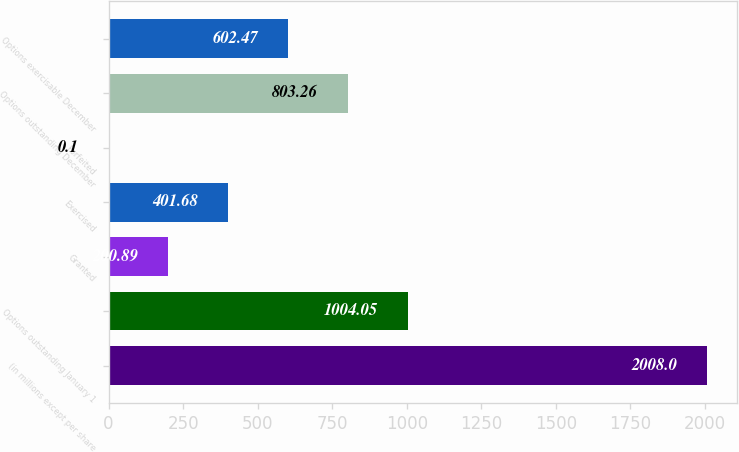<chart> <loc_0><loc_0><loc_500><loc_500><bar_chart><fcel>(in millions except per share<fcel>Options outstanding January 1<fcel>Granted<fcel>Exercised<fcel>Forfeited<fcel>Options outstanding December<fcel>Options exercisable December<nl><fcel>2008<fcel>1004.05<fcel>200.89<fcel>401.68<fcel>0.1<fcel>803.26<fcel>602.47<nl></chart> 